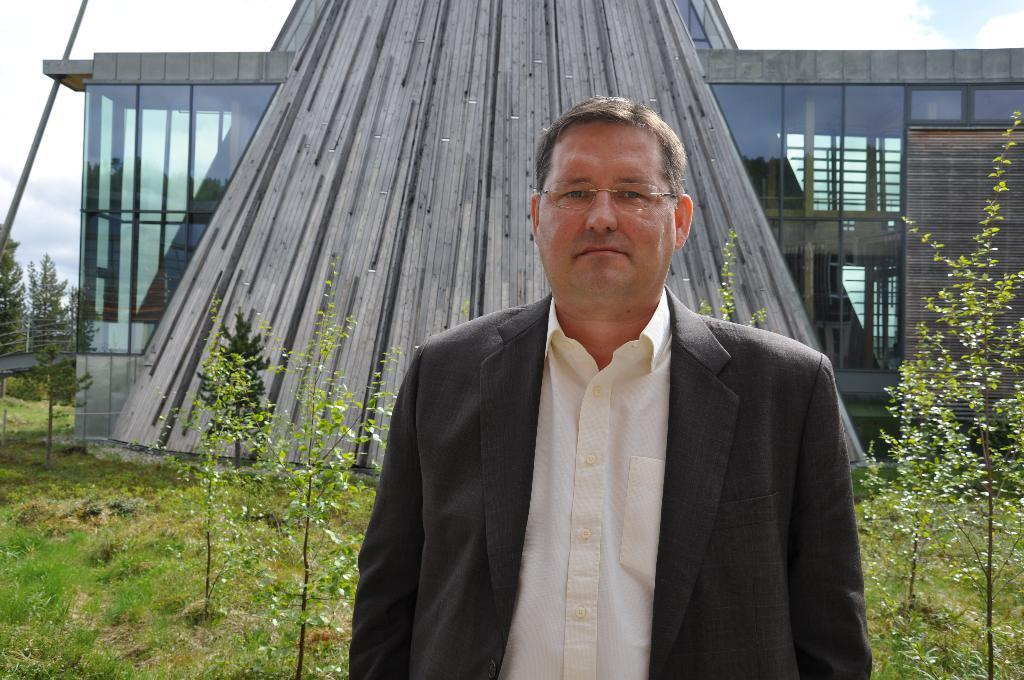What is the person in the image wearing? The person is wearing a suit and glasses. What can be seen in the background of the image? There are plants and architecture in the background of the image. What type of jam is the person eating while sitting on the throne in the image? There is no jam or throne present in the image; the person is standing and wearing a suit and glasses. 